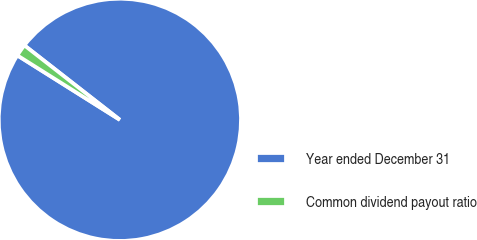Convert chart to OTSL. <chart><loc_0><loc_0><loc_500><loc_500><pie_chart><fcel>Year ended December 31<fcel>Common dividend payout ratio<nl><fcel>98.39%<fcel>1.61%<nl></chart> 